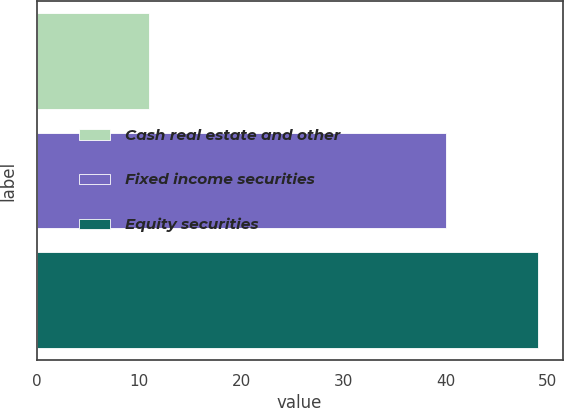Convert chart to OTSL. <chart><loc_0><loc_0><loc_500><loc_500><bar_chart><fcel>Cash real estate and other<fcel>Fixed income securities<fcel>Equity securities<nl><fcel>11<fcel>40<fcel>49<nl></chart> 